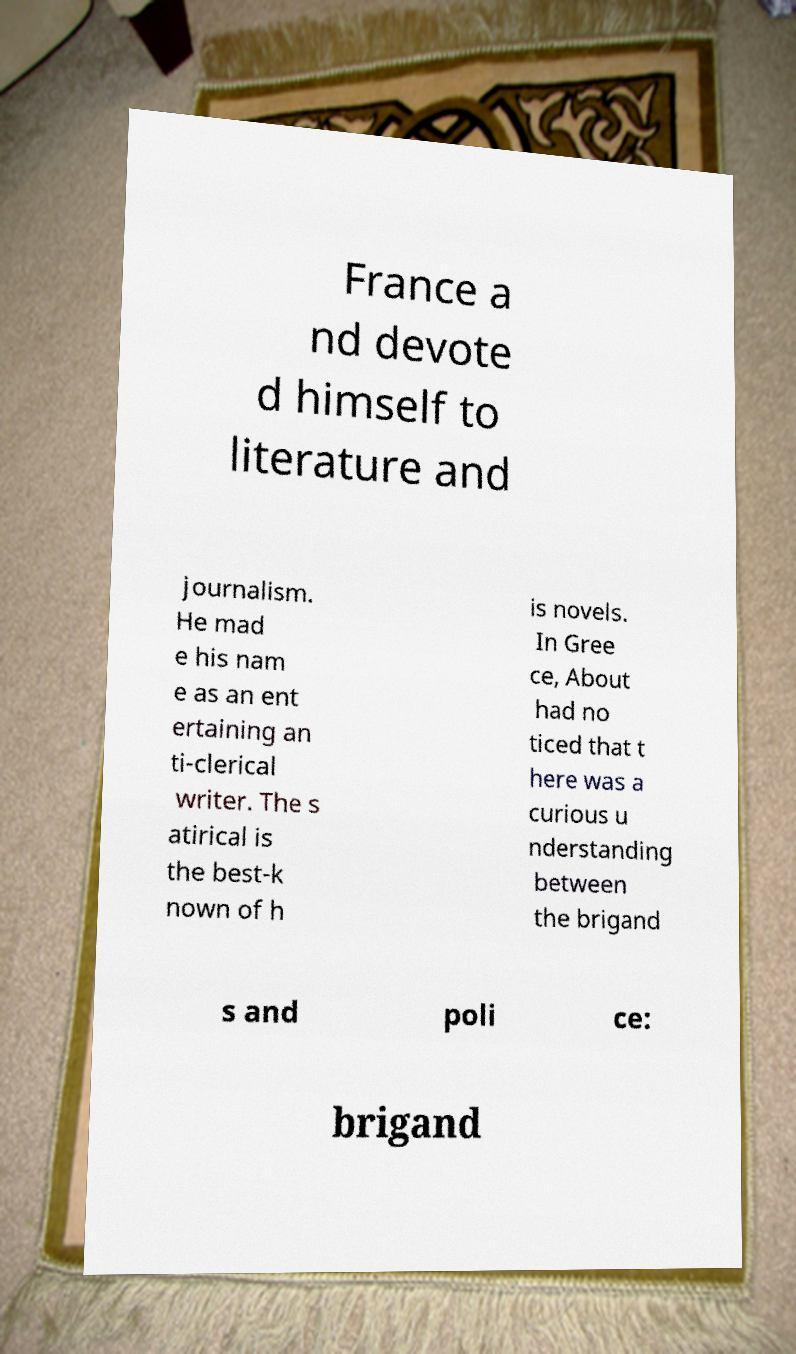For documentation purposes, I need the text within this image transcribed. Could you provide that? France a nd devote d himself to literature and journalism. He mad e his nam e as an ent ertaining an ti-clerical writer. The s atirical is the best-k nown of h is novels. In Gree ce, About had no ticed that t here was a curious u nderstanding between the brigand s and poli ce: brigand 